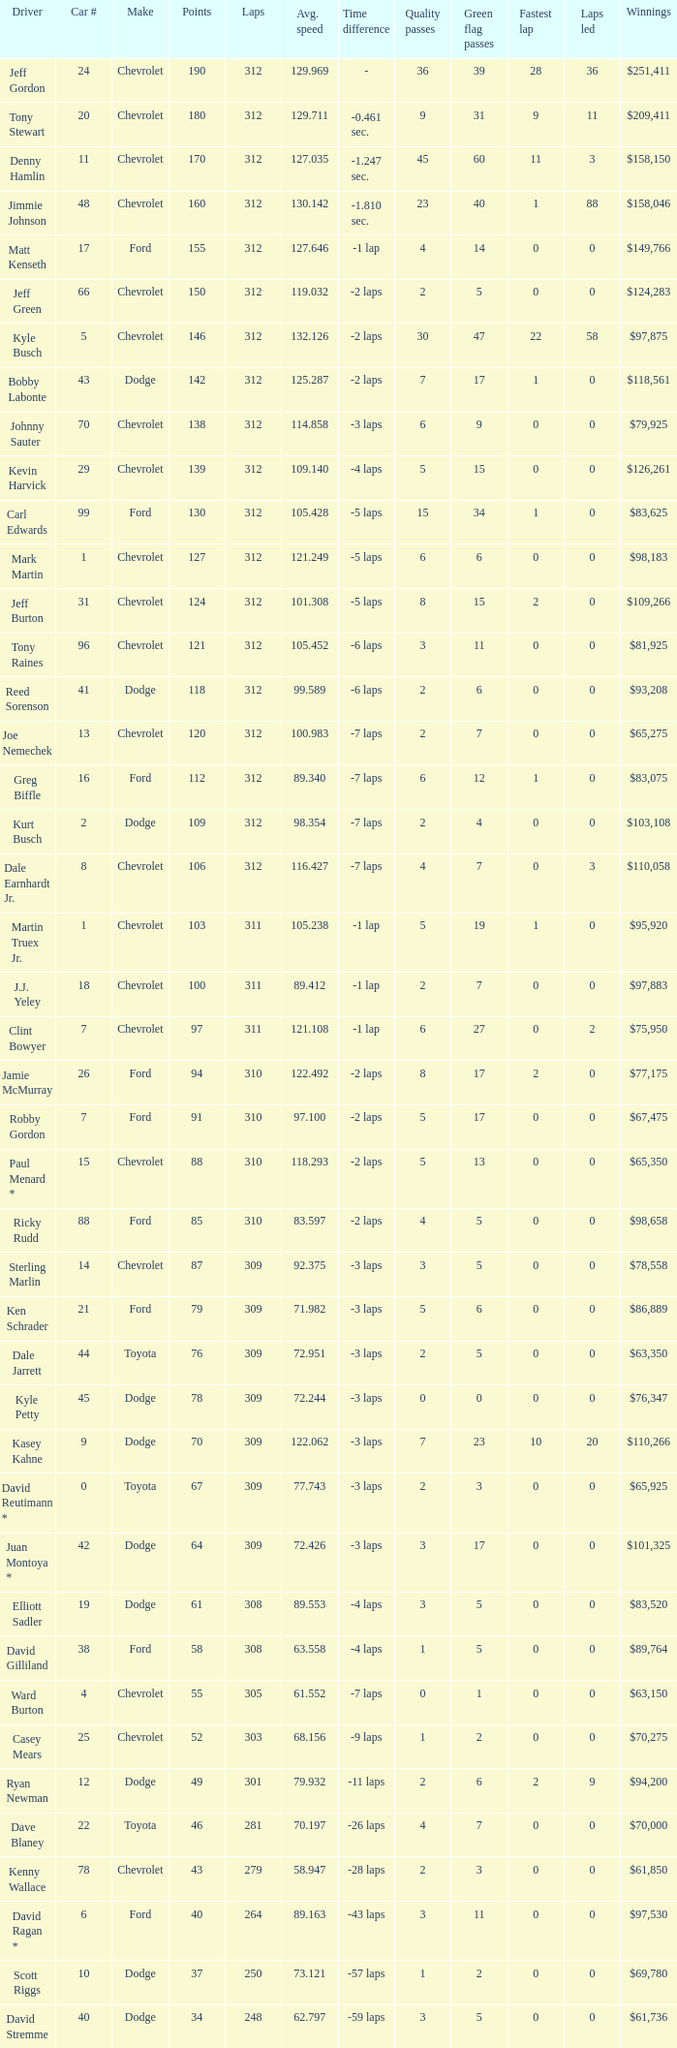What is the lowest number of laps for kyle petty with under 118 points? 309.0. 